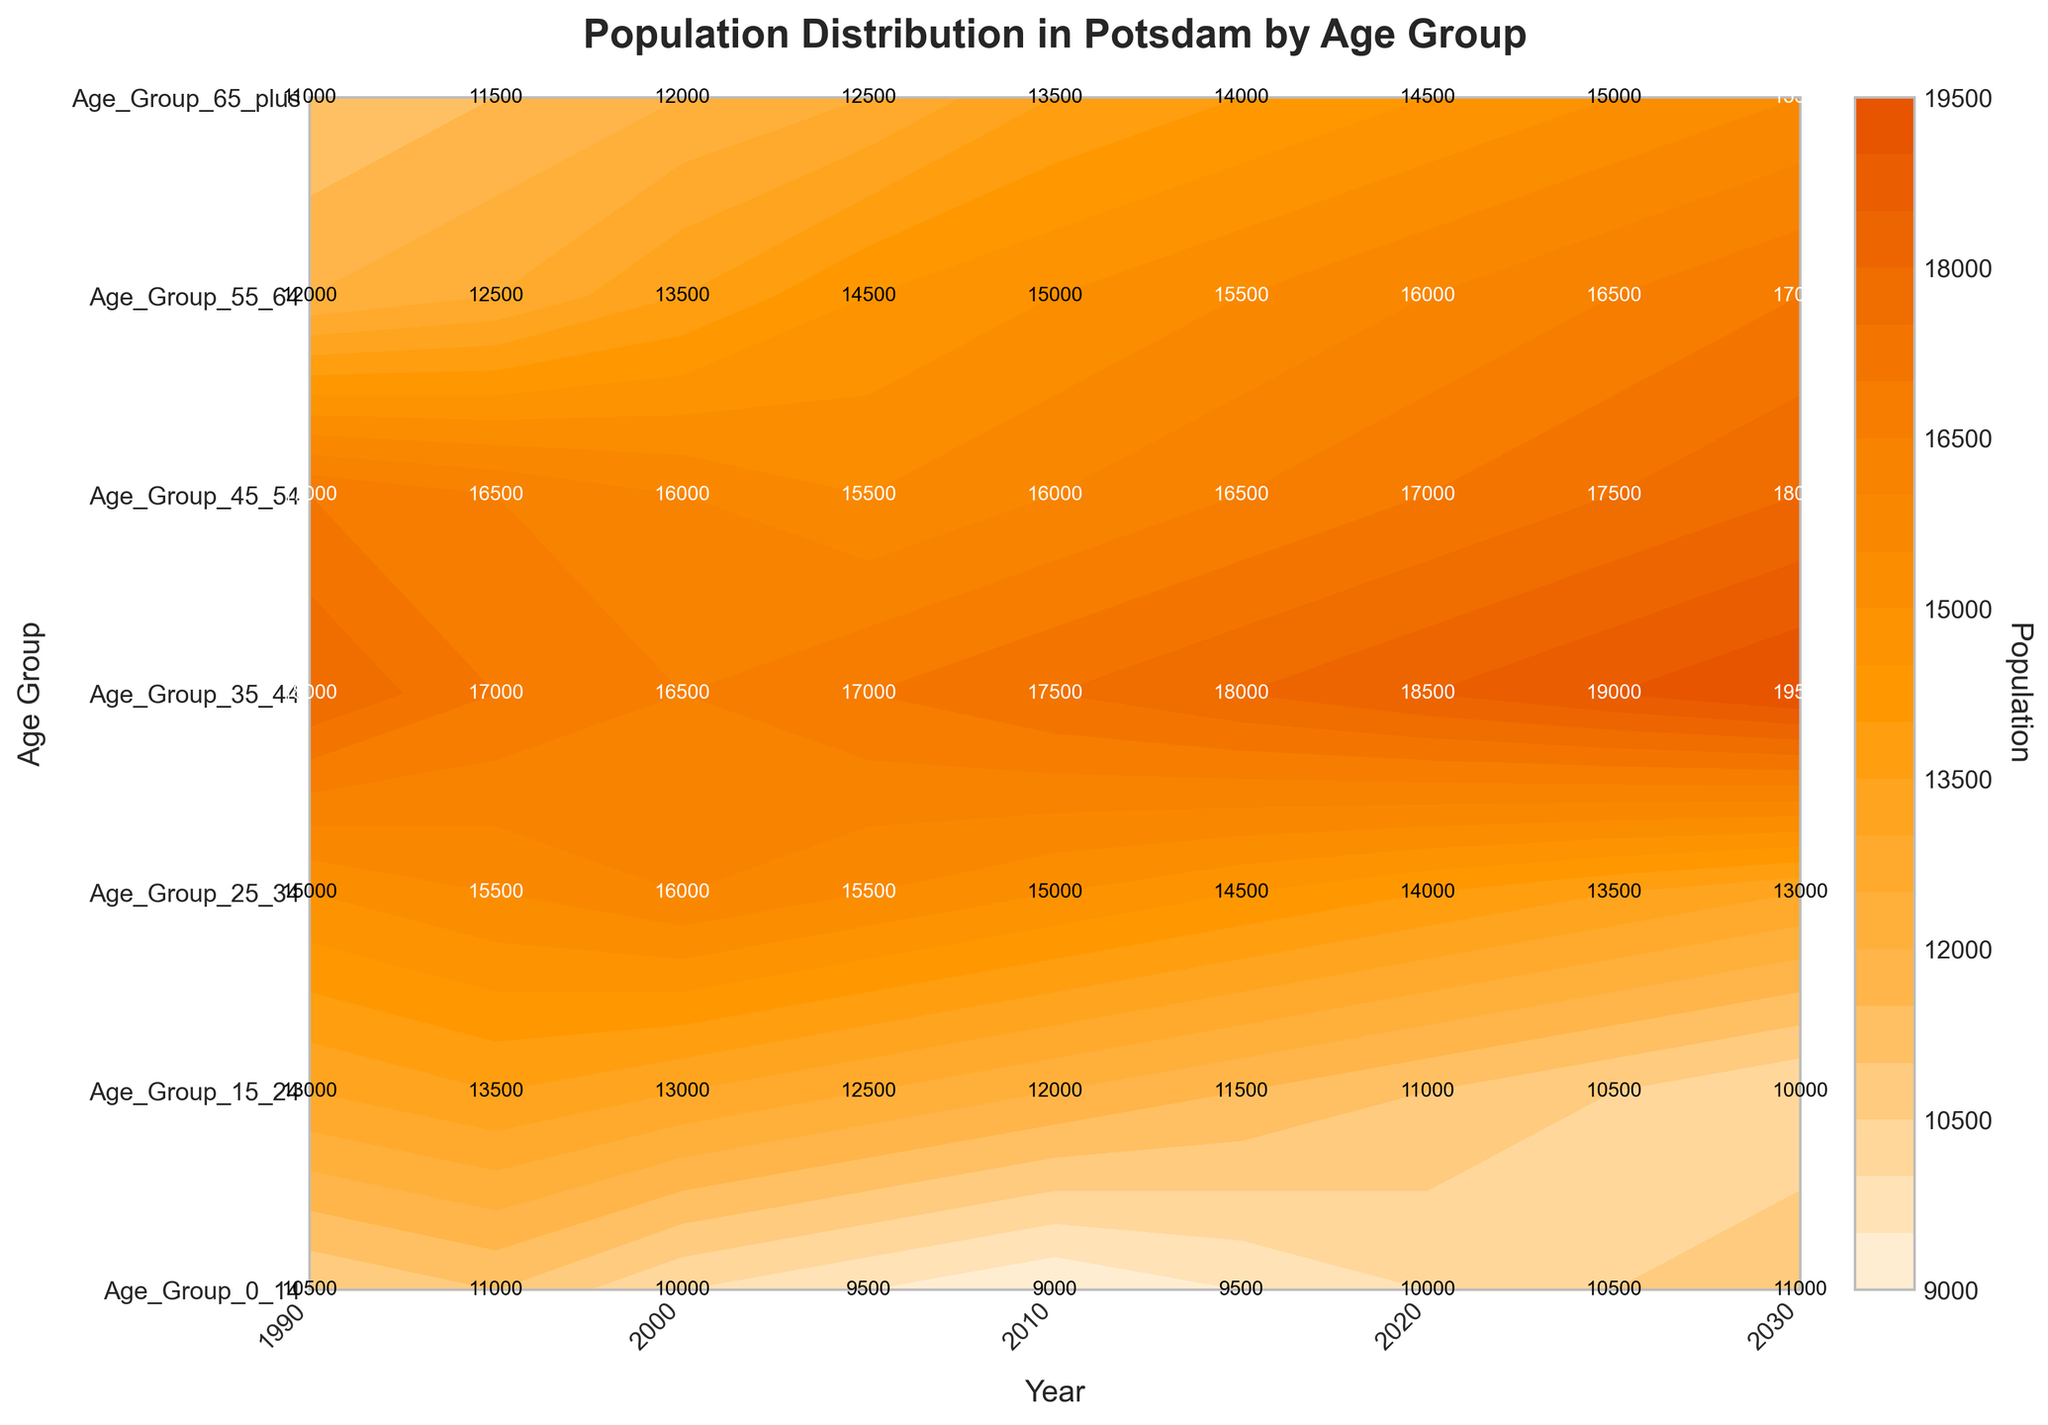What is the highest population recorded for the age group 25-34? The figure shows population distributions for different age groups over time. By inspecting the values within the "Age_Group_25_34" row, we notice the highest value is 16000 which occurs in the year 2000.
Answer: 16000 Which year shows the lowest population for the age group 0-14? By following the "Age_Group_0_14" along the years, the lowest population recorded is 9000 in the year 2010.
Answer: 2010 Did the population of the age group 65+ grow monotonically over the years? By checking the data points in the "Age_Group_65_plus", we observe that the population values are consistently increasing from 11000 in 1990 to 15500 in 2030 without any decrease, hence growing monotonically.
Answer: Yes Which age group had the highest population in 2015? By comparing the population numbers for all age groups in the year 2015, we find that "Age_Group_35_44" had the highest population of 18000.
Answer: Age_Group_35_44 How does the population of the age group 15-24 in 2000 compare to 2005? Observing the "Age_Group_15_24" for the years 2000 and 2005, the population in 2000 is 13000 while in 2005 it is 12500. The population decreases by 500.
Answer: Decreases What are the two age groups with the smallest total increase in population from 1990 to 2030? Calculating the difference between the 2030 and 1990 values for each age group, Age_Group_55_64 increased by 5000 (17000-12000) and Age_Group_15_24 increased by 3000 (10000-13000), which are the smallest increases.
Answer: Age_Group_55_64, Age_Group_15_24 During which year did the population of all age groups become lower than 15000? By scanning for the years where all population values under 15000, the only common year is 2020.
Answer: 2020 What is the overall trend for the population of the age group 45-54? The age group 45-54 shows an overall increasing trend when moving from 17000 in 1990 to 18000 in 2030 with minor fluctuations.
Answer: Increasing Which age group saw the most fluctuation (highest standard deviation) in population between 1990 and 2030? Calculating the standard deviation of populations for each age group, Age_Group_35_44 has the highest fluctuation from 18000 (1990) to 19500(2030).
Answer: Age_Group_35_44 When was the only year that "Age_Group_0_14" had a population equal to 11000? Examining the figure, the population for "Age_Group_0_14" equaled 11000 only in 2025, based on the table.
Answer: 2025 